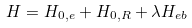<formula> <loc_0><loc_0><loc_500><loc_500>H = H _ { 0 , e } + H _ { 0 , R } + \lambda H _ { e b }</formula> 